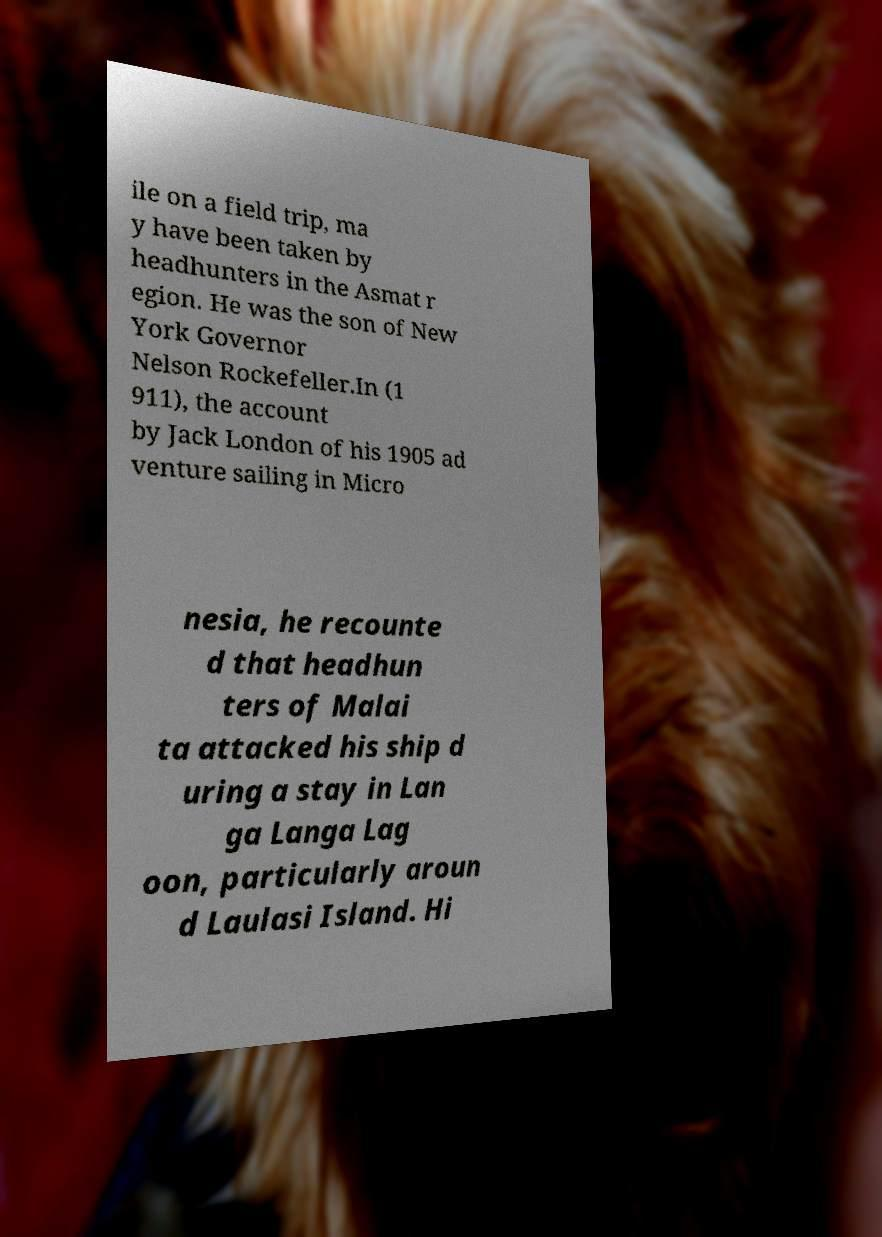I need the written content from this picture converted into text. Can you do that? ile on a field trip, ma y have been taken by headhunters in the Asmat r egion. He was the son of New York Governor Nelson Rockefeller.In (1 911), the account by Jack London of his 1905 ad venture sailing in Micro nesia, he recounte d that headhun ters of Malai ta attacked his ship d uring a stay in Lan ga Langa Lag oon, particularly aroun d Laulasi Island. Hi 